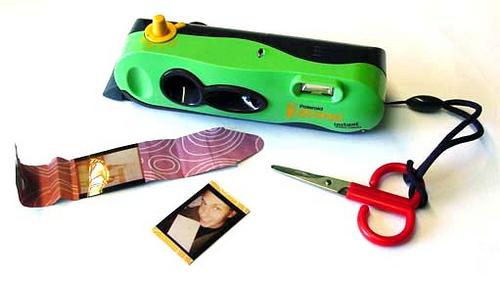What color are the scissors?
Be succinct. Red. What color is the sheet?
Answer briefly. White. Is the person in the picture smiling?
Be succinct. Yes. What color surface are the objects sitting on?
Quick response, please. White. 